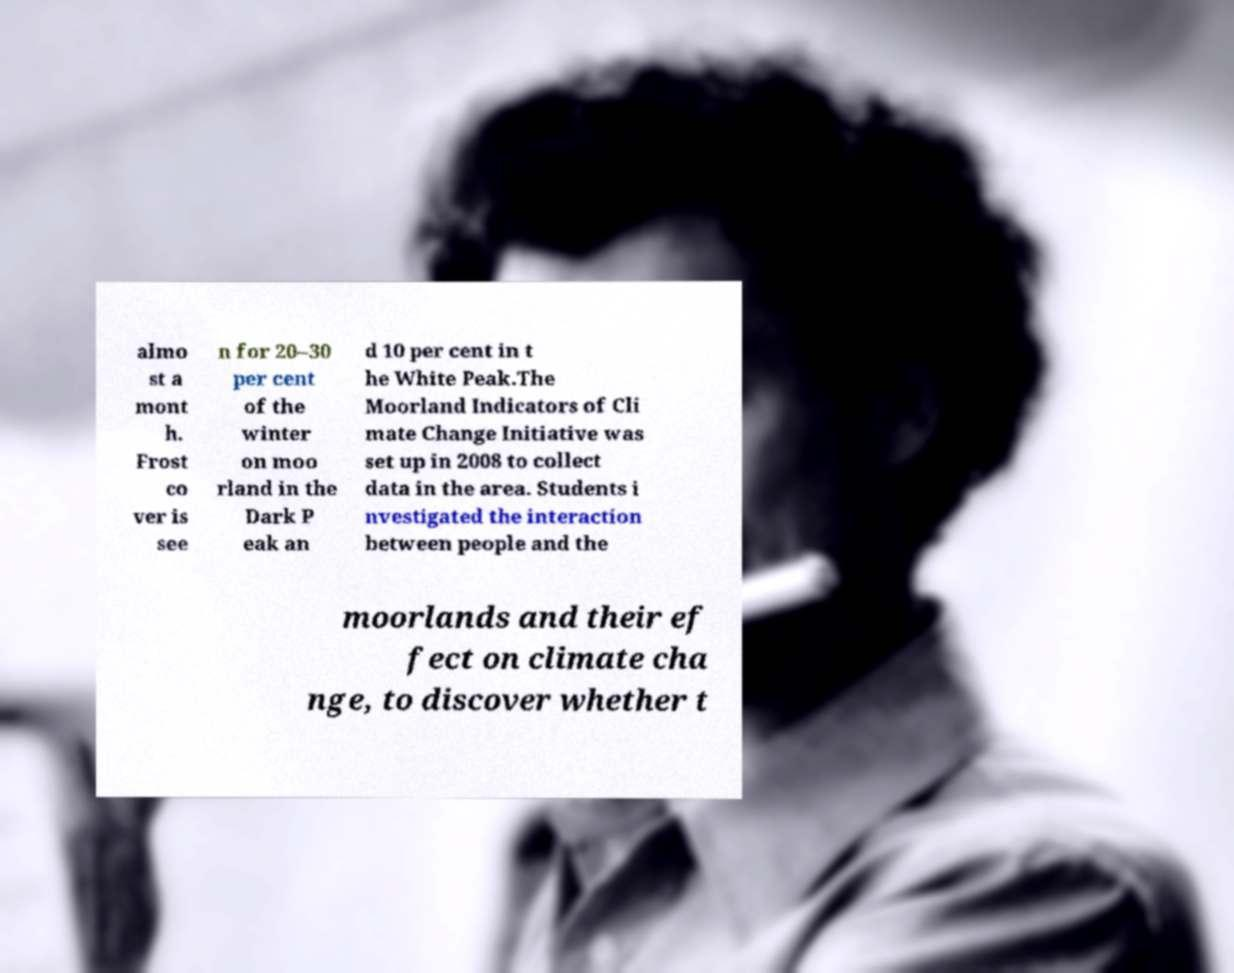Could you extract and type out the text from this image? almo st a mont h. Frost co ver is see n for 20–30 per cent of the winter on moo rland in the Dark P eak an d 10 per cent in t he White Peak.The Moorland Indicators of Cli mate Change Initiative was set up in 2008 to collect data in the area. Students i nvestigated the interaction between people and the moorlands and their ef fect on climate cha nge, to discover whether t 